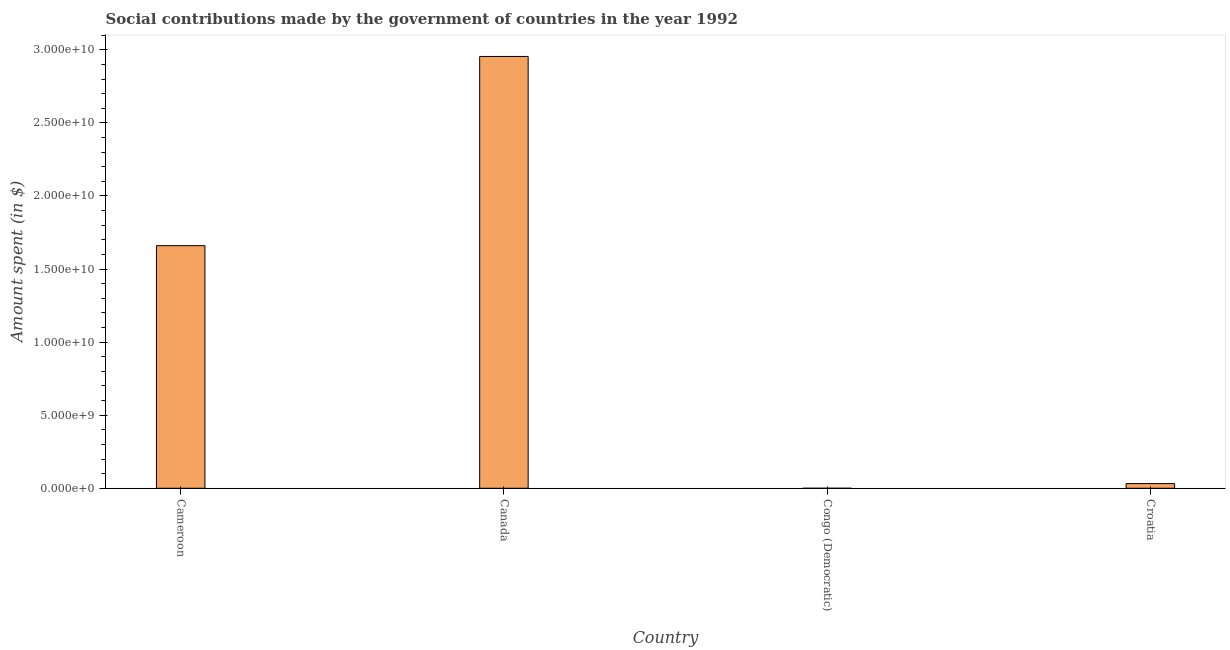What is the title of the graph?
Your answer should be compact. Social contributions made by the government of countries in the year 1992. What is the label or title of the X-axis?
Provide a succinct answer. Country. What is the label or title of the Y-axis?
Give a very brief answer. Amount spent (in $). What is the amount spent in making social contributions in Congo (Democratic)?
Offer a terse response. 10. Across all countries, what is the maximum amount spent in making social contributions?
Your answer should be very brief. 2.95e+1. In which country was the amount spent in making social contributions minimum?
Offer a very short reply. Congo (Democratic). What is the sum of the amount spent in making social contributions?
Your answer should be compact. 4.65e+1. What is the difference between the amount spent in making social contributions in Cameroon and Congo (Democratic)?
Make the answer very short. 1.66e+1. What is the average amount spent in making social contributions per country?
Offer a terse response. 1.16e+1. What is the median amount spent in making social contributions?
Your answer should be very brief. 8.46e+09. In how many countries, is the amount spent in making social contributions greater than 17000000000 $?
Offer a terse response. 1. What is the ratio of the amount spent in making social contributions in Canada to that in Croatia?
Your answer should be very brief. 91.97. Is the amount spent in making social contributions in Cameroon less than that in Congo (Democratic)?
Provide a succinct answer. No. What is the difference between the highest and the second highest amount spent in making social contributions?
Offer a very short reply. 1.29e+1. What is the difference between the highest and the lowest amount spent in making social contributions?
Keep it short and to the point. 2.95e+1. Are all the bars in the graph horizontal?
Provide a succinct answer. No. What is the difference between two consecutive major ticks on the Y-axis?
Make the answer very short. 5.00e+09. Are the values on the major ticks of Y-axis written in scientific E-notation?
Keep it short and to the point. Yes. What is the Amount spent (in $) in Cameroon?
Your answer should be very brief. 1.66e+1. What is the Amount spent (in $) of Canada?
Your answer should be compact. 2.95e+1. What is the Amount spent (in $) in Congo (Democratic)?
Your answer should be very brief. 10. What is the Amount spent (in $) in Croatia?
Give a very brief answer. 3.21e+08. What is the difference between the Amount spent (in $) in Cameroon and Canada?
Ensure brevity in your answer.  -1.29e+1. What is the difference between the Amount spent (in $) in Cameroon and Congo (Democratic)?
Your response must be concise. 1.66e+1. What is the difference between the Amount spent (in $) in Cameroon and Croatia?
Ensure brevity in your answer.  1.63e+1. What is the difference between the Amount spent (in $) in Canada and Congo (Democratic)?
Give a very brief answer. 2.95e+1. What is the difference between the Amount spent (in $) in Canada and Croatia?
Offer a very short reply. 2.92e+1. What is the difference between the Amount spent (in $) in Congo (Democratic) and Croatia?
Provide a succinct answer. -3.21e+08. What is the ratio of the Amount spent (in $) in Cameroon to that in Canada?
Provide a succinct answer. 0.56. What is the ratio of the Amount spent (in $) in Cameroon to that in Congo (Democratic)?
Ensure brevity in your answer.  1.66e+09. What is the ratio of the Amount spent (in $) in Cameroon to that in Croatia?
Ensure brevity in your answer.  51.67. What is the ratio of the Amount spent (in $) in Canada to that in Congo (Democratic)?
Give a very brief answer. 2.95e+09. What is the ratio of the Amount spent (in $) in Canada to that in Croatia?
Give a very brief answer. 91.97. What is the ratio of the Amount spent (in $) in Congo (Democratic) to that in Croatia?
Offer a terse response. 0. 